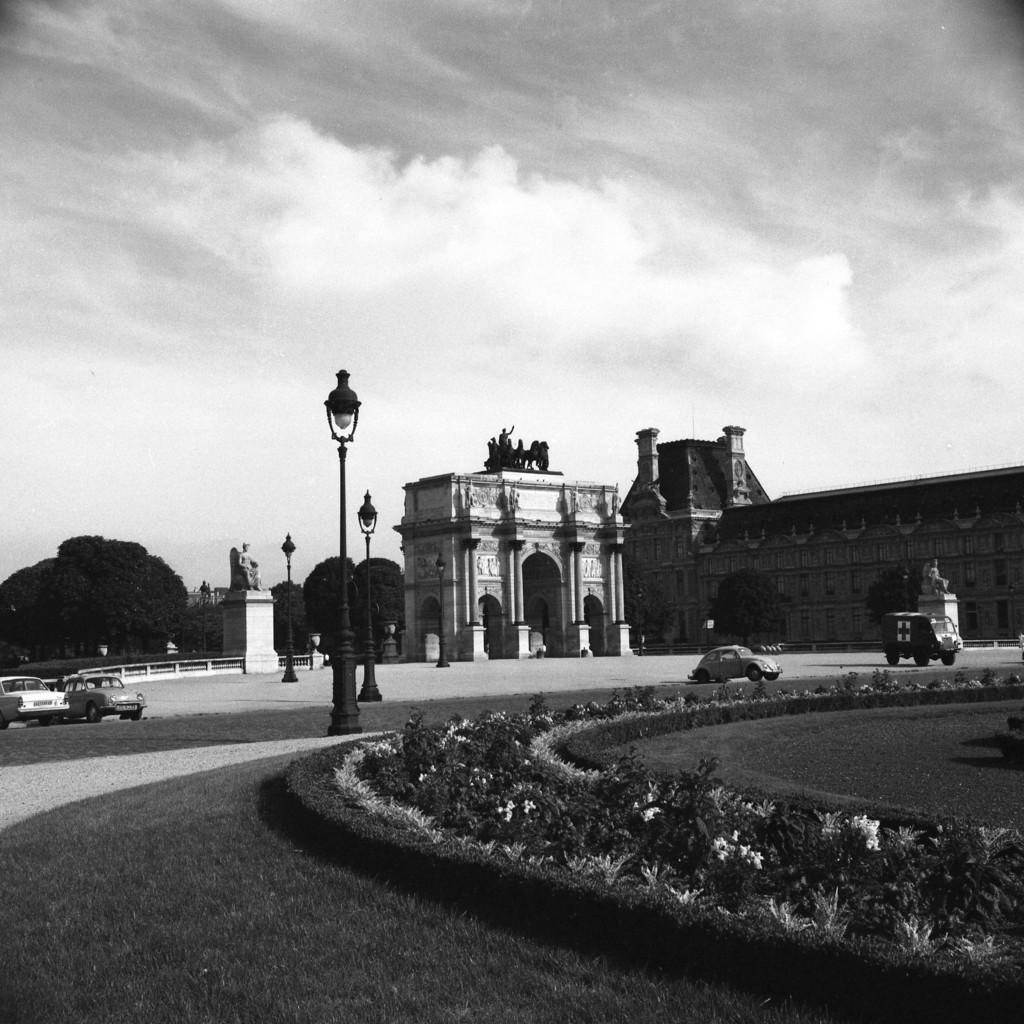What is the color scheme of the image? The image is black and white. What type of structure can be seen in the image? There is a building in the image. What other natural elements are present in the image? There are trees in the image. What type of urban infrastructure is visible in the image? There are street light poles in the image. What mode of transportation can be seen in the image? There are cars on the road in the image. What type of outdoor area is present in the image? There is a garden with plants in the image. Can you tell me how many cats are sitting on the street light poles in the image? There are no cats present in the image; it only features a building, trees, street light poles, cars, and a garden. What channel is the image from? The image is not from a channel, as it is a still image and not a video or broadcast. 